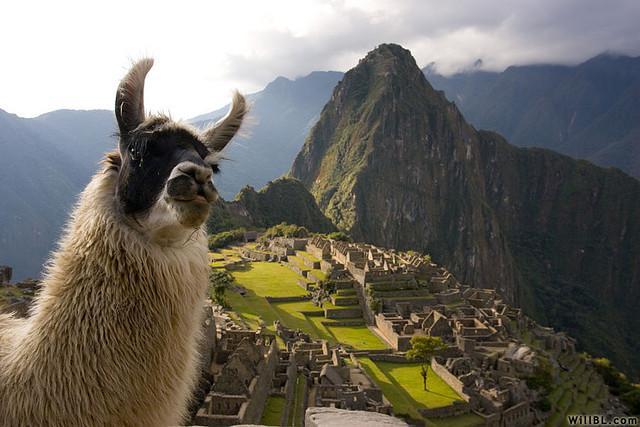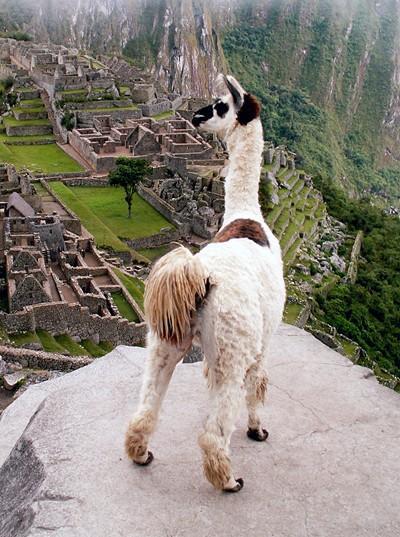The first image is the image on the left, the second image is the image on the right. Given the left and right images, does the statement "In one image there is a person standing next to a llama and in the other image there is a llama decorated with yarn." hold true? Answer yes or no. No. The first image is the image on the left, the second image is the image on the right. For the images displayed, is the sentence "LLamas are showing off their colorful and festive attire." factually correct? Answer yes or no. No. 